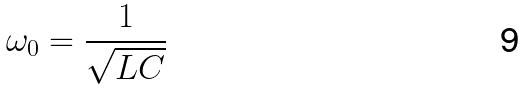<formula> <loc_0><loc_0><loc_500><loc_500>\omega _ { 0 } = \frac { 1 } { \sqrt { L C } }</formula> 